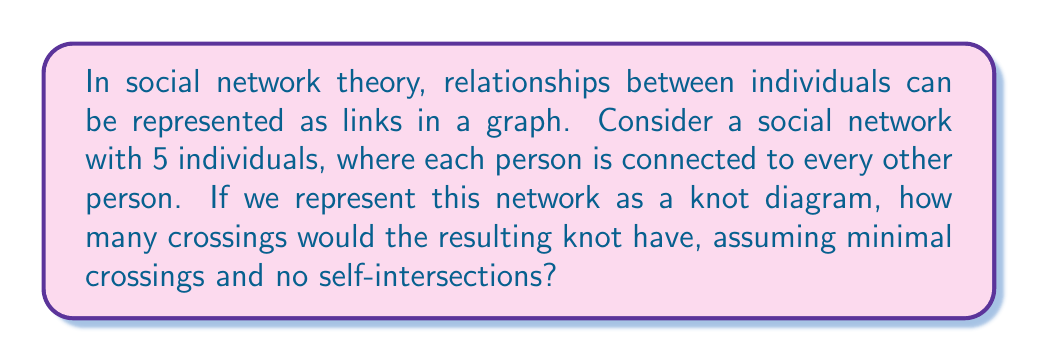Could you help me with this problem? To solve this problem, let's approach it step-by-step:

1. In a complete graph with 5 vertices (representing 5 individuals), each vertex is connected to every other vertex. The number of edges in such a graph is given by the formula:

   $$\text{Number of edges} = \frac{n(n-1)}{2}$$

   Where $n$ is the number of vertices.

2. Substituting $n=5$:
   $$\text{Number of edges} = \frac{5(5-1)}{2} = \frac{5 \times 4}{2} = 10$$

3. In knot theory, when we represent a graph as a knot diagram, each edge becomes a strand of the knot, and the vertices become points where multiple strands meet.

4. The number of crossings in a minimal crossing diagram of a knot derived from a complete graph is given by the formula:

   $$\text{Number of crossings} = \binom{n}{4}$$

   This formula counts the number of ways to choose 4 vertices from n vertices, as each set of 4 vertices contributes one crossing in the minimal representation.

5. Calculating $\binom{5}{4}$:
   $$\binom{5}{4} = \frac{5!}{4!(5-4)!} = \frac{5 \times 4 \times 3 \times 2 \times 1}{(4 \times 3 \times 2 \times 1)(1)} = 5$$

Therefore, the resulting knot diagram would have 5 crossings.

This representation allows us to visualize the interconnectedness of the social network as a physical structure, where the complexity of relationships is reflected in the number of crossings in the knot.
Answer: 5 crossings 